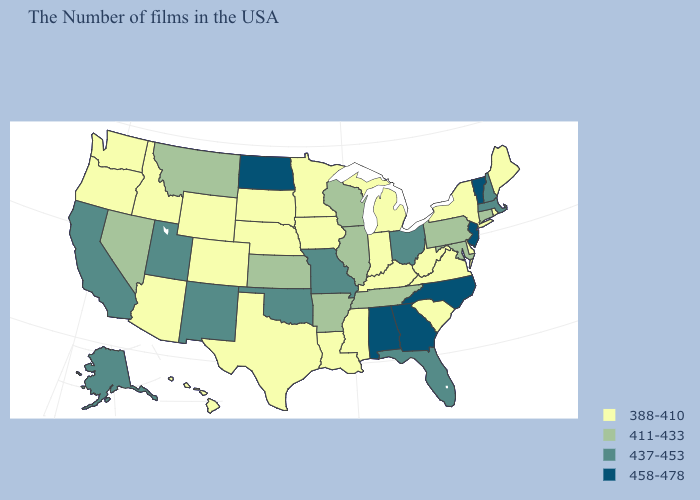What is the lowest value in the USA?
Answer briefly. 388-410. What is the highest value in the USA?
Answer briefly. 458-478. Does South Carolina have the lowest value in the South?
Concise answer only. Yes. What is the highest value in states that border Vermont?
Quick response, please. 437-453. Name the states that have a value in the range 388-410?
Concise answer only. Maine, Rhode Island, New York, Delaware, Virginia, South Carolina, West Virginia, Michigan, Kentucky, Indiana, Mississippi, Louisiana, Minnesota, Iowa, Nebraska, Texas, South Dakota, Wyoming, Colorado, Arizona, Idaho, Washington, Oregon, Hawaii. Name the states that have a value in the range 458-478?
Answer briefly. Vermont, New Jersey, North Carolina, Georgia, Alabama, North Dakota. What is the lowest value in the South?
Keep it brief. 388-410. Which states have the lowest value in the Northeast?
Give a very brief answer. Maine, Rhode Island, New York. Does Vermont have a lower value than Mississippi?
Concise answer only. No. What is the lowest value in the South?
Keep it brief. 388-410. Among the states that border Montana , does North Dakota have the lowest value?
Concise answer only. No. What is the value of Wisconsin?
Short answer required. 411-433. What is the value of Ohio?
Write a very short answer. 437-453. Does Georgia have the highest value in the South?
Quick response, please. Yes. Name the states that have a value in the range 437-453?
Be succinct. Massachusetts, New Hampshire, Ohio, Florida, Missouri, Oklahoma, New Mexico, Utah, California, Alaska. 